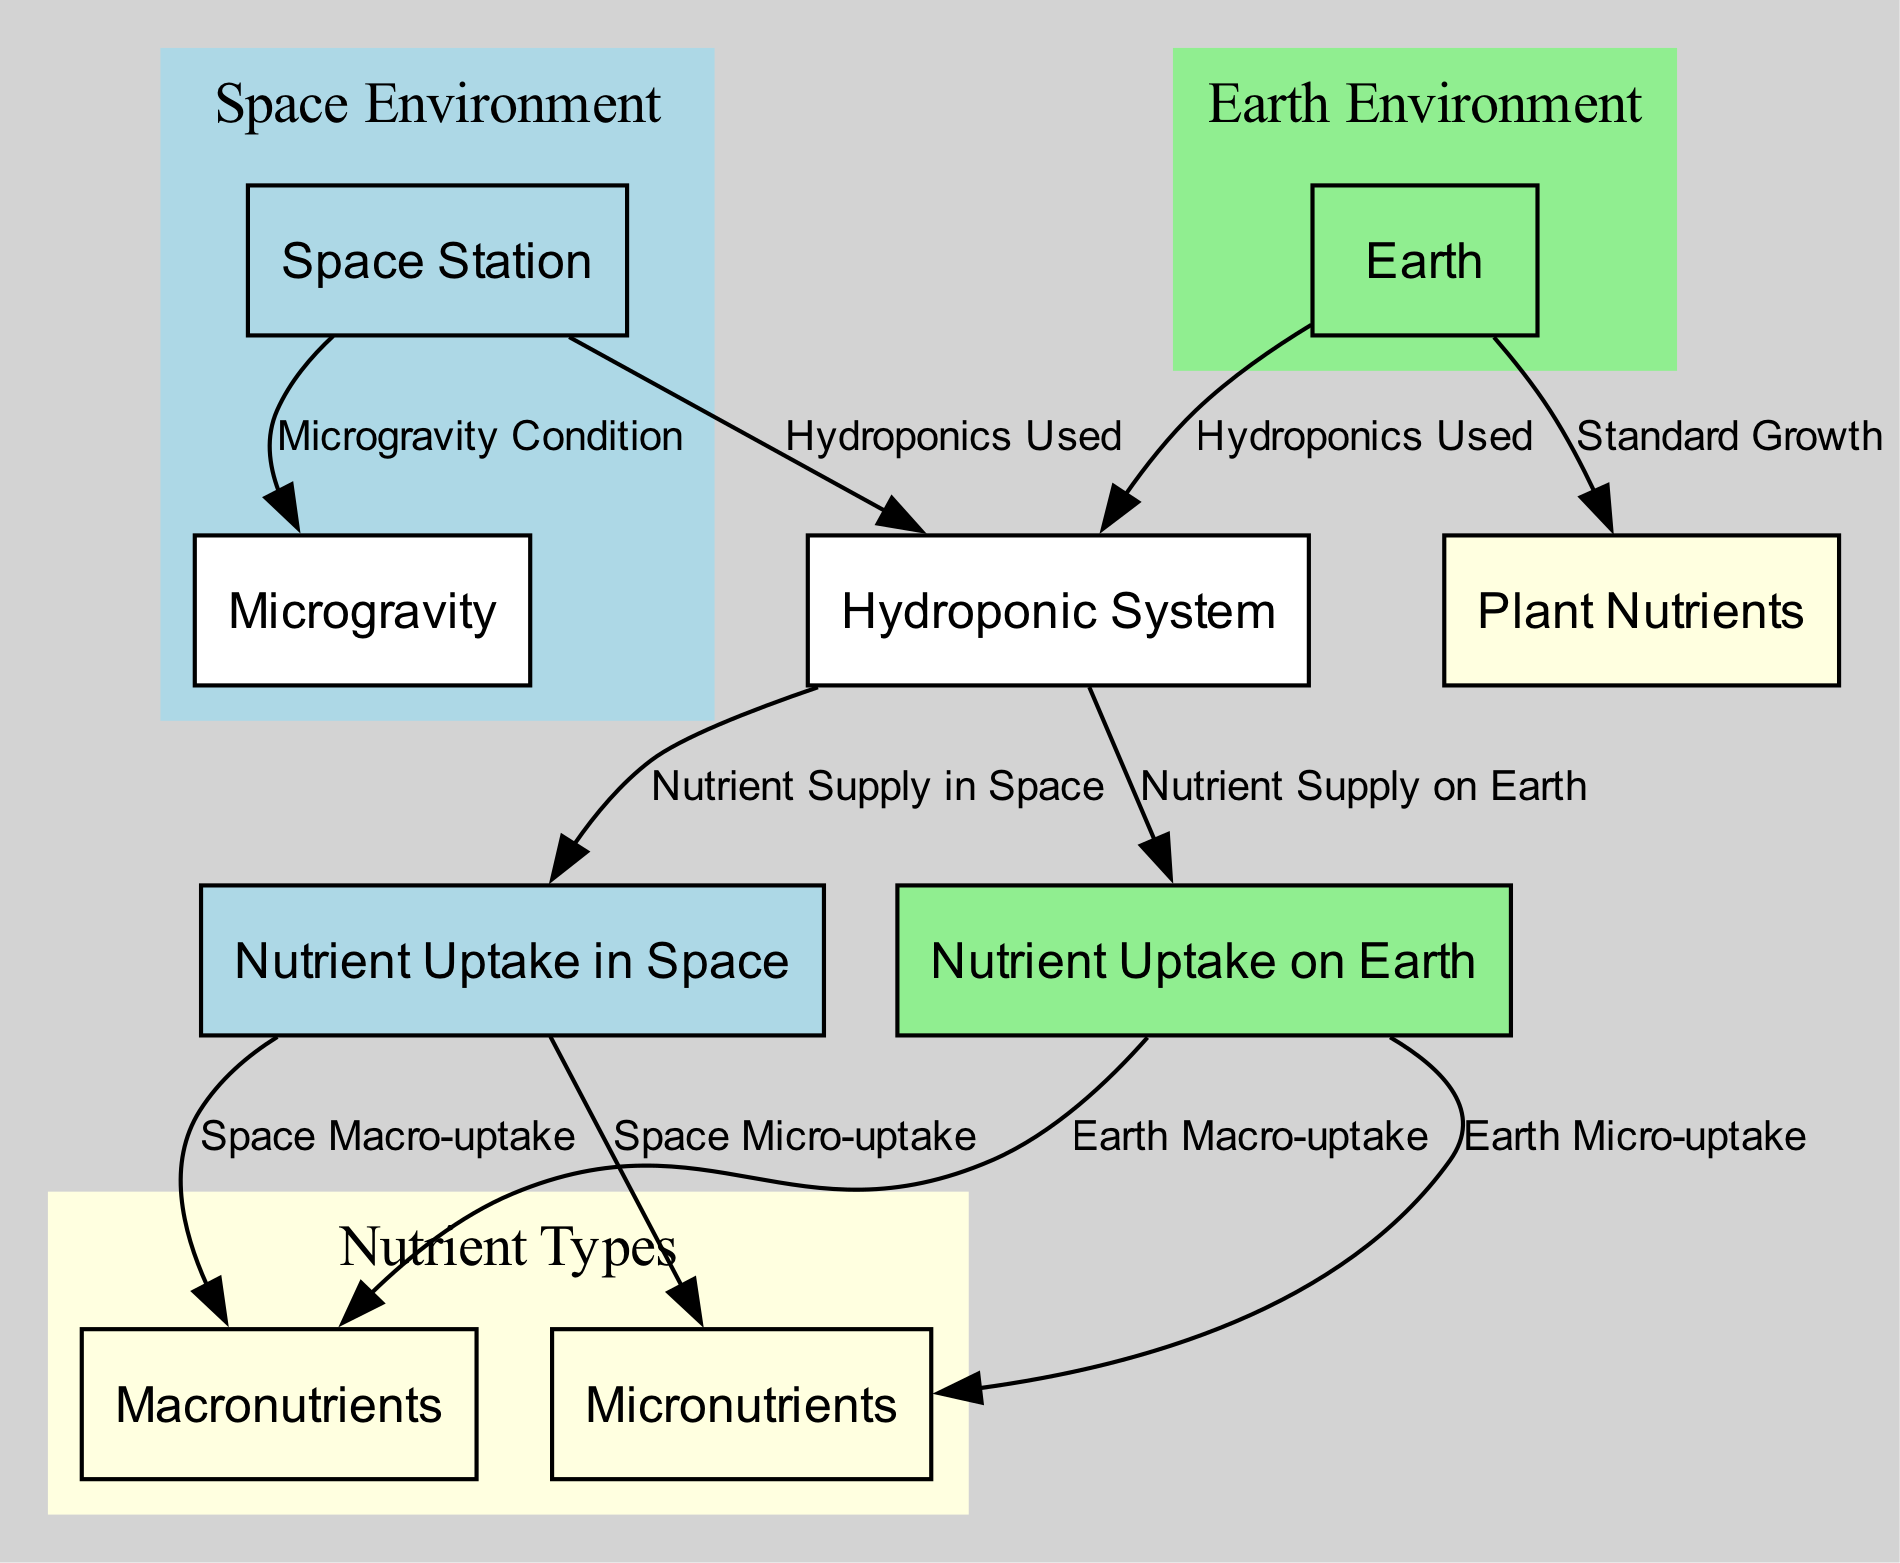What is the environment for plant growth in microgravity? The diagram specifies the 'Space Station' as the environment providing conditions for plant growth in microgravity. This is directly labeled on the node as 'Space Station'.
Answer: Space Station Which nutrient types are highlighted in the diagram? The diagram has nodes for 'Macronutrients' and 'Micronutrients', indicating that these two categories of nutrients are discussed in relation to plants.
Answer: Macronutrients, Micronutrients What type of growth medium is used in the space station according to the diagram? The diagram shows 'Hydroponic System' connected to 'Space Station', indicating that this soil-less growth medium is utilized for plant growth in that environment.
Answer: Hydroponic System How does nutrient uptake in microgravity compare to nutrient uptake on Earth for macronutrients? The diagram indicates edges leading from both 'Nutrient Uptake in Space' and 'Nutrient Uptake on Earth' to 'Macronutrients', suggesting both environments absorb these nutrients but it doesn't detail the comparison quantitatively. Hence, they both absorb macronutrients, but the differences aren't shown.
Answer: Both absorb macronutrients What is the relationship between the hydroponic system and nutrient supply in space? The diagram indicates that the 'Hydroponic System' provides 'Nutrient Supply in Space', signaling a direct relationship where the hydroponic system facilitates nutrient absorption by plants grown in that environment.
Answer: Nutrient Supply in Space How many edges are associated with nutrient uptake on Earth? The diagram shows two edges connecting from 'Nutrient Uptake on Earth' to both 'Macronutrients' and 'Micronutrients', implying there are two linked relationships for nutrient uptake on that environment.
Answer: 2 What condition is described as a 'Low-gravity condition in space'? The term 'Microgravity' is defined in the diagram as a low-gravity environment in space, directly relating to plant growth conditions.
Answer: Microgravity Which nutrients are associated with plants in microgravity? The 'Nutrient Uptake in Space' node connects to both 'Macronutrients' and 'Micronutrients', indicating that plants in microgravity absorb both types of nutrients.
Answer: Macronutrients, Micronutrients 